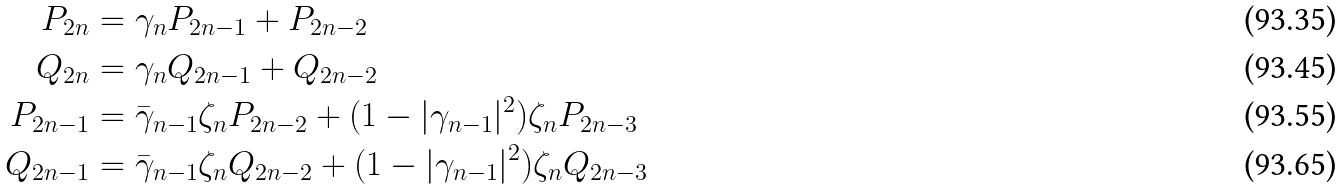<formula> <loc_0><loc_0><loc_500><loc_500>P _ { 2 n } & = \gamma _ { n } P _ { 2 n - 1 } + P _ { 2 n - 2 } \\ Q _ { 2 n } & = \gamma _ { n } Q _ { 2 n - 1 } + Q _ { 2 n - 2 } \\ P _ { 2 n - 1 } & = \bar { \gamma } _ { n - 1 } \zeta _ { n } P _ { 2 n - 2 } + ( 1 - | \gamma _ { n - 1 } | ^ { 2 } ) \zeta _ { n } P _ { 2 n - 3 } \\ Q _ { 2 n - 1 } & = \bar { \gamma } _ { n - 1 } \zeta _ { n } Q _ { 2 n - 2 } + ( 1 - | \gamma _ { n - 1 } | ^ { 2 } ) \zeta _ { n } Q _ { 2 n - 3 }</formula> 